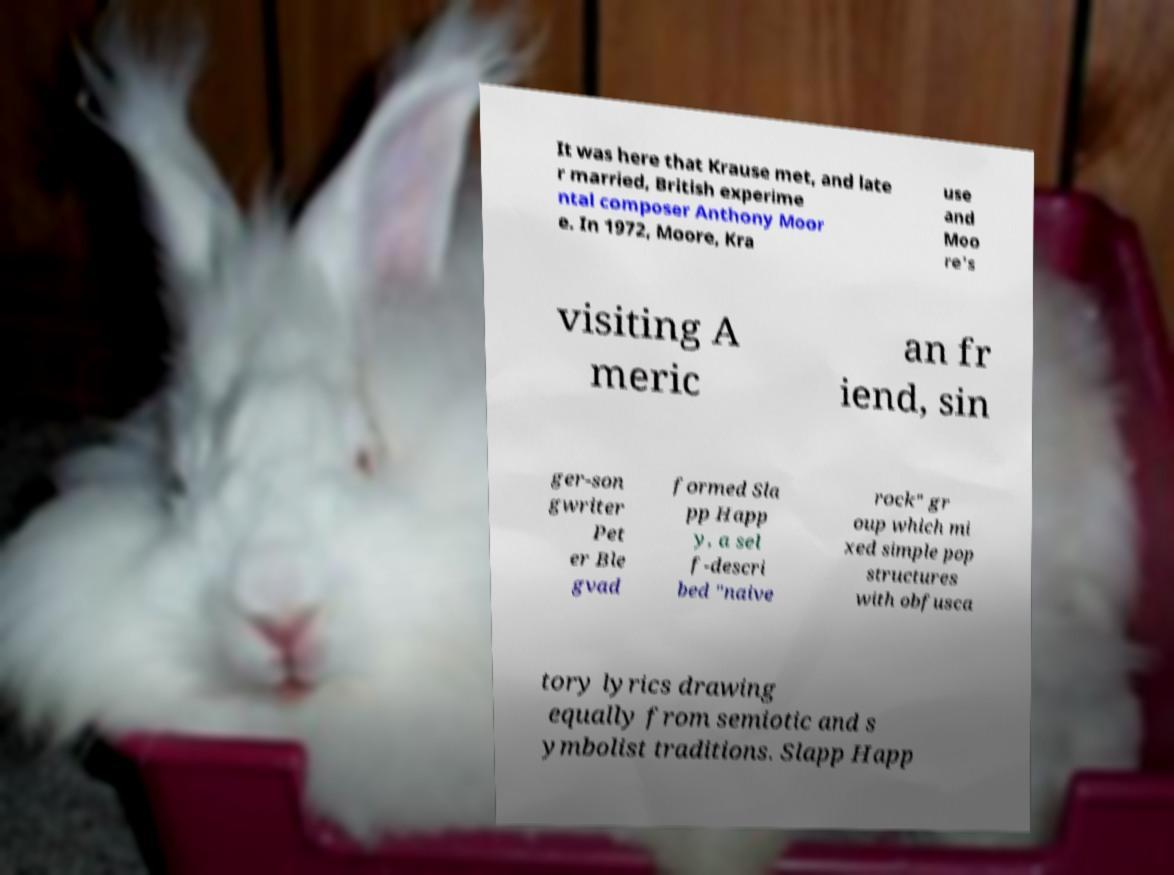Please identify and transcribe the text found in this image. It was here that Krause met, and late r married, British experime ntal composer Anthony Moor e. In 1972, Moore, Kra use and Moo re's visiting A meric an fr iend, sin ger-son gwriter Pet er Ble gvad formed Sla pp Happ y, a sel f-descri bed "naive rock" gr oup which mi xed simple pop structures with obfusca tory lyrics drawing equally from semiotic and s ymbolist traditions. Slapp Happ 